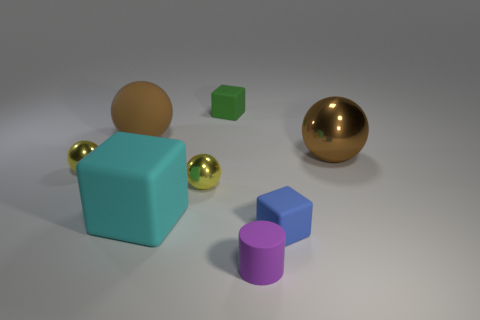Is the big matte sphere the same color as the large shiny object?
Ensure brevity in your answer.  Yes. The other tiny block that is the same material as the tiny green block is what color?
Offer a terse response. Blue. There is a blue rubber object that is the same size as the purple cylinder; what is its shape?
Give a very brief answer. Cube. Is there a small purple cylinder behind the metal sphere that is on the left side of the big cyan rubber cube?
Provide a succinct answer. No. How many blocks are green rubber objects or big metallic things?
Ensure brevity in your answer.  1. Are there any other big brown things that have the same shape as the brown shiny object?
Offer a terse response. Yes. There is a small purple object; what shape is it?
Keep it short and to the point. Cylinder. How many objects are big brown blocks or big brown metal spheres?
Ensure brevity in your answer.  1. Does the yellow sphere right of the brown rubber object have the same size as the cyan matte block that is to the left of the green thing?
Your answer should be compact. No. How many other things are there of the same material as the cylinder?
Your answer should be very brief. 4. 